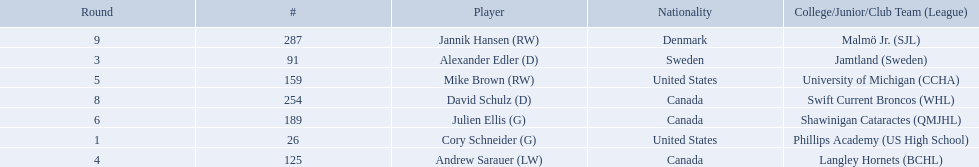What are the names of the colleges and jr leagues the players attended? Phillips Academy (US High School), Jamtland (Sweden), Langley Hornets (BCHL), University of Michigan (CCHA), Shawinigan Cataractes (QMJHL), Swift Current Broncos (WHL), Malmö Jr. (SJL). Which player played for the langley hornets? Andrew Sarauer (LW). 